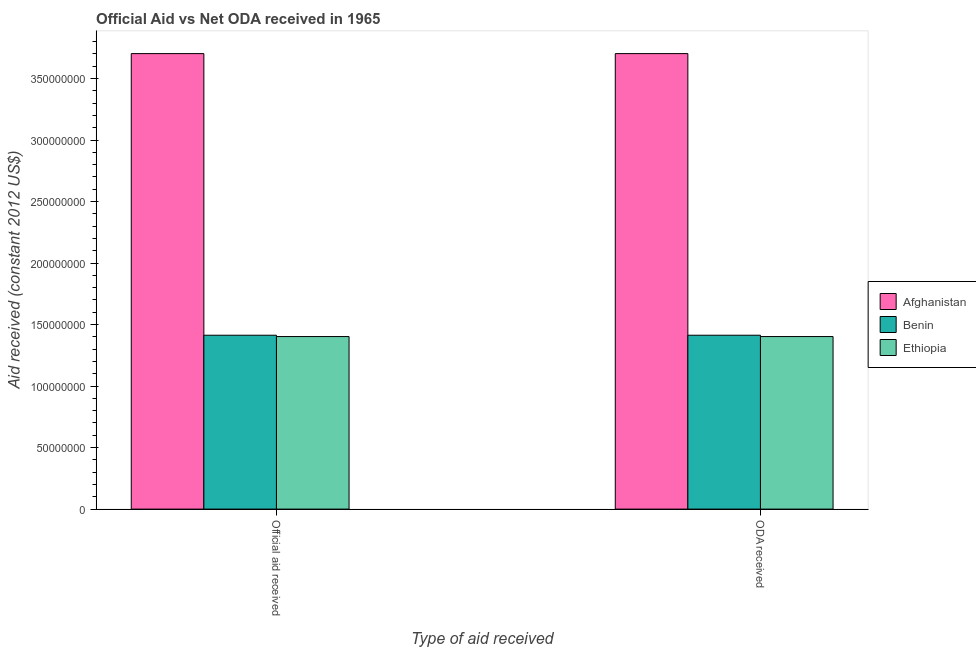How many groups of bars are there?
Make the answer very short. 2. Are the number of bars on each tick of the X-axis equal?
Keep it short and to the point. Yes. How many bars are there on the 1st tick from the right?
Provide a short and direct response. 3. What is the label of the 1st group of bars from the left?
Keep it short and to the point. Official aid received. What is the oda received in Afghanistan?
Your answer should be very brief. 3.70e+08. Across all countries, what is the maximum official aid received?
Your answer should be compact. 3.70e+08. Across all countries, what is the minimum official aid received?
Keep it short and to the point. 1.40e+08. In which country was the official aid received maximum?
Offer a very short reply. Afghanistan. In which country was the official aid received minimum?
Keep it short and to the point. Ethiopia. What is the total official aid received in the graph?
Provide a succinct answer. 6.52e+08. What is the difference between the official aid received in Ethiopia and that in Afghanistan?
Give a very brief answer. -2.30e+08. What is the difference between the oda received in Benin and the official aid received in Afghanistan?
Provide a short and direct response. -2.29e+08. What is the average oda received per country?
Make the answer very short. 2.17e+08. What is the difference between the official aid received and oda received in Ethiopia?
Ensure brevity in your answer.  0. What is the ratio of the oda received in Afghanistan to that in Benin?
Your answer should be very brief. 2.62. Is the official aid received in Benin less than that in Ethiopia?
Provide a short and direct response. No. In how many countries, is the oda received greater than the average oda received taken over all countries?
Make the answer very short. 1. What does the 2nd bar from the left in Official aid received represents?
Offer a terse response. Benin. What does the 3rd bar from the right in Official aid received represents?
Your answer should be very brief. Afghanistan. How many bars are there?
Offer a terse response. 6. Are all the bars in the graph horizontal?
Keep it short and to the point. No. How many countries are there in the graph?
Your response must be concise. 3. What is the difference between two consecutive major ticks on the Y-axis?
Offer a terse response. 5.00e+07. Does the graph contain any zero values?
Offer a very short reply. No. Does the graph contain grids?
Make the answer very short. No. What is the title of the graph?
Offer a very short reply. Official Aid vs Net ODA received in 1965 . What is the label or title of the X-axis?
Provide a short and direct response. Type of aid received. What is the label or title of the Y-axis?
Offer a terse response. Aid received (constant 2012 US$). What is the Aid received (constant 2012 US$) in Afghanistan in Official aid received?
Provide a succinct answer. 3.70e+08. What is the Aid received (constant 2012 US$) of Benin in Official aid received?
Keep it short and to the point. 1.41e+08. What is the Aid received (constant 2012 US$) in Ethiopia in Official aid received?
Your answer should be very brief. 1.40e+08. What is the Aid received (constant 2012 US$) in Afghanistan in ODA received?
Provide a short and direct response. 3.70e+08. What is the Aid received (constant 2012 US$) of Benin in ODA received?
Your answer should be compact. 1.41e+08. What is the Aid received (constant 2012 US$) of Ethiopia in ODA received?
Offer a terse response. 1.40e+08. Across all Type of aid received, what is the maximum Aid received (constant 2012 US$) of Afghanistan?
Give a very brief answer. 3.70e+08. Across all Type of aid received, what is the maximum Aid received (constant 2012 US$) in Benin?
Provide a short and direct response. 1.41e+08. Across all Type of aid received, what is the maximum Aid received (constant 2012 US$) in Ethiopia?
Keep it short and to the point. 1.40e+08. Across all Type of aid received, what is the minimum Aid received (constant 2012 US$) in Afghanistan?
Give a very brief answer. 3.70e+08. Across all Type of aid received, what is the minimum Aid received (constant 2012 US$) of Benin?
Keep it short and to the point. 1.41e+08. Across all Type of aid received, what is the minimum Aid received (constant 2012 US$) in Ethiopia?
Offer a very short reply. 1.40e+08. What is the total Aid received (constant 2012 US$) of Afghanistan in the graph?
Keep it short and to the point. 7.41e+08. What is the total Aid received (constant 2012 US$) of Benin in the graph?
Make the answer very short. 2.83e+08. What is the total Aid received (constant 2012 US$) in Ethiopia in the graph?
Provide a short and direct response. 2.81e+08. What is the difference between the Aid received (constant 2012 US$) in Benin in Official aid received and that in ODA received?
Your answer should be very brief. 0. What is the difference between the Aid received (constant 2012 US$) in Ethiopia in Official aid received and that in ODA received?
Keep it short and to the point. 0. What is the difference between the Aid received (constant 2012 US$) in Afghanistan in Official aid received and the Aid received (constant 2012 US$) in Benin in ODA received?
Give a very brief answer. 2.29e+08. What is the difference between the Aid received (constant 2012 US$) of Afghanistan in Official aid received and the Aid received (constant 2012 US$) of Ethiopia in ODA received?
Offer a terse response. 2.30e+08. What is the difference between the Aid received (constant 2012 US$) of Benin in Official aid received and the Aid received (constant 2012 US$) of Ethiopia in ODA received?
Give a very brief answer. 1.08e+06. What is the average Aid received (constant 2012 US$) of Afghanistan per Type of aid received?
Make the answer very short. 3.70e+08. What is the average Aid received (constant 2012 US$) in Benin per Type of aid received?
Make the answer very short. 1.41e+08. What is the average Aid received (constant 2012 US$) in Ethiopia per Type of aid received?
Offer a terse response. 1.40e+08. What is the difference between the Aid received (constant 2012 US$) of Afghanistan and Aid received (constant 2012 US$) of Benin in Official aid received?
Ensure brevity in your answer.  2.29e+08. What is the difference between the Aid received (constant 2012 US$) of Afghanistan and Aid received (constant 2012 US$) of Ethiopia in Official aid received?
Your answer should be compact. 2.30e+08. What is the difference between the Aid received (constant 2012 US$) in Benin and Aid received (constant 2012 US$) in Ethiopia in Official aid received?
Your answer should be very brief. 1.08e+06. What is the difference between the Aid received (constant 2012 US$) of Afghanistan and Aid received (constant 2012 US$) of Benin in ODA received?
Offer a very short reply. 2.29e+08. What is the difference between the Aid received (constant 2012 US$) in Afghanistan and Aid received (constant 2012 US$) in Ethiopia in ODA received?
Provide a succinct answer. 2.30e+08. What is the difference between the Aid received (constant 2012 US$) in Benin and Aid received (constant 2012 US$) in Ethiopia in ODA received?
Your response must be concise. 1.08e+06. What is the ratio of the Aid received (constant 2012 US$) in Afghanistan in Official aid received to that in ODA received?
Your response must be concise. 1. What is the ratio of the Aid received (constant 2012 US$) in Benin in Official aid received to that in ODA received?
Make the answer very short. 1. What is the difference between the highest and the second highest Aid received (constant 2012 US$) of Benin?
Offer a terse response. 0. What is the difference between the highest and the second highest Aid received (constant 2012 US$) in Ethiopia?
Your answer should be very brief. 0. What is the difference between the highest and the lowest Aid received (constant 2012 US$) in Benin?
Your answer should be compact. 0. 